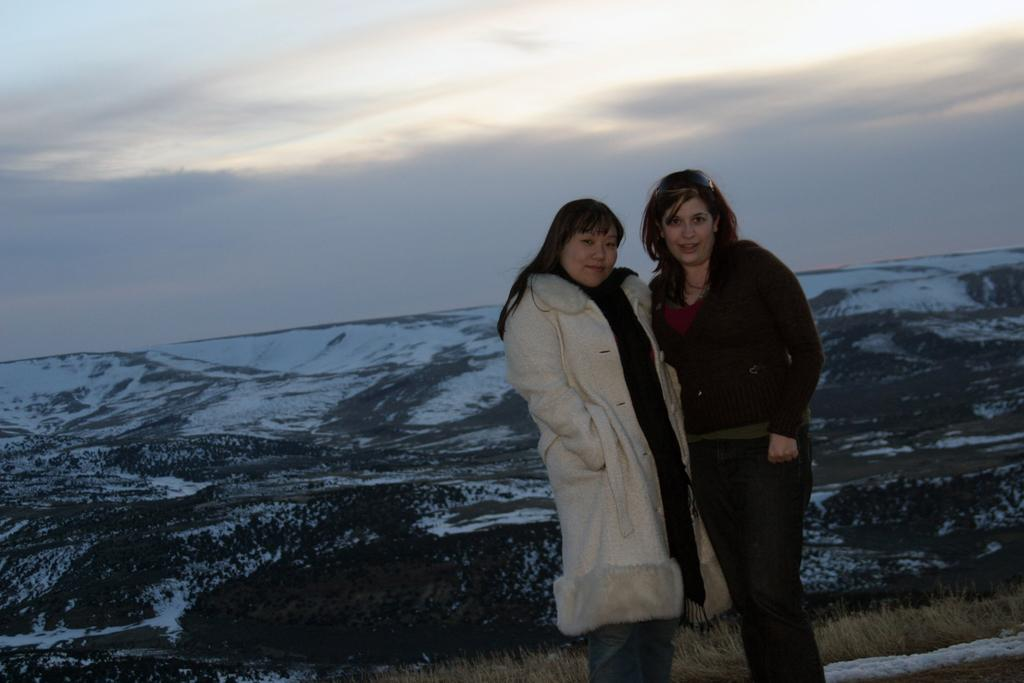How many people are in the image? There are two women standing in the image. What is the facial expression of the women in the image? The women are smiling. What type of landscape is depicted in the image? The image appears to depict a snowy mountain. What type of vegetation can be seen in the image? There is dried grass visible in the image. What is visible in the sky in the image? The sky is visible in the image. What type of impulse can be seen affecting the swing in the image? There is no swing present in the image, so it is not possible to determine if any impulse is affecting it. 